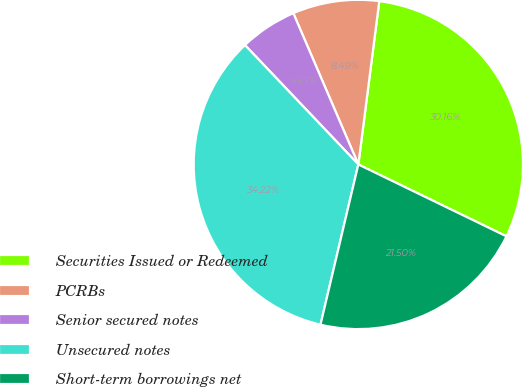Convert chart. <chart><loc_0><loc_0><loc_500><loc_500><pie_chart><fcel>Securities Issued or Redeemed<fcel>PCRBs<fcel>Senior secured notes<fcel>Unsecured notes<fcel>Short-term borrowings net<nl><fcel>30.16%<fcel>8.49%<fcel>5.63%<fcel>34.22%<fcel>21.5%<nl></chart> 